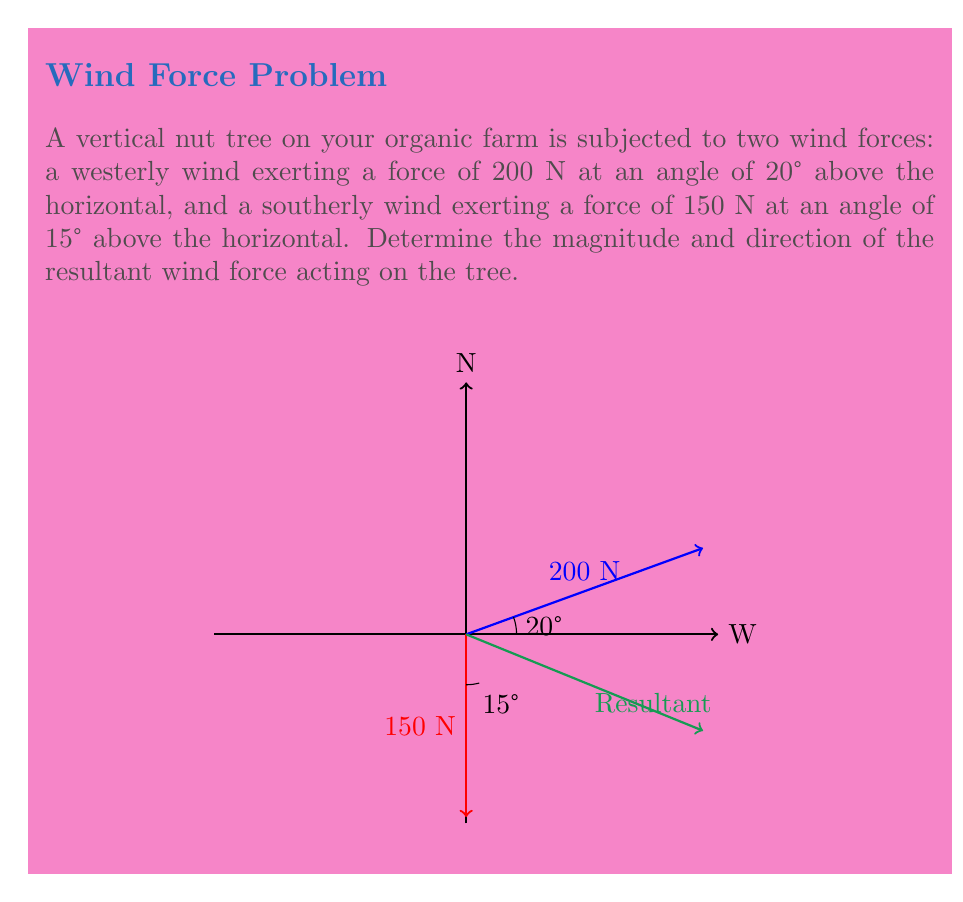Can you answer this question? Let's solve this problem step by step:

1) First, we need to break down each force into its horizontal and vertical components.

   For the westerly wind:
   $F_x = 200 \cos(20°) = 187.94$ N (East)
   $F_y = 200 \sin(20°) = 68.40$ N (North)

   For the southerly wind:
   $F_x = 0$ N
   $F_y = -150 \cos(15°) = -144.96$ N (South)

2) Now, we sum the components:
   $F_x(\text{total}) = 187.94$ N
   $F_y(\text{total}) = 68.40 - 144.96 = -76.56$ N

3) The magnitude of the resultant force can be calculated using the Pythagorean theorem:

   $F_{\text{resultant}} = \sqrt{F_x^2 + F_y^2} = \sqrt{187.94^2 + (-76.56)^2} = 203.17$ N

4) The direction of the resultant force can be found using the arctangent function:

   $\theta = \arctan(\frac{F_y}{F_x}) = \arctan(\frac{-76.56}{187.94}) = -22.15°$

   Since this angle is measured from the positive x-axis (East), and it's negative, the actual direction is 22.15° South of East.
Answer: $203.17$ N, $22.15°$ South of East 